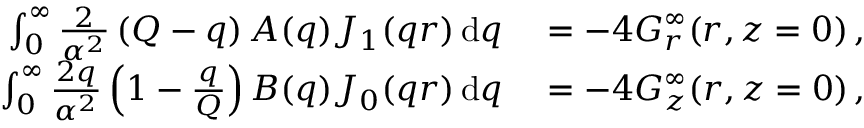Convert formula to latex. <formula><loc_0><loc_0><loc_500><loc_500>\begin{array} { r l } { \int _ { 0 } ^ { \infty } \frac { 2 } { \alpha ^ { 2 } } \left ( Q - q \right ) A ( q ) J _ { 1 } ( q r ) \, d q } & = - 4 G _ { r } ^ { \infty } ( r , z = 0 ) \, , } \\ { \int _ { 0 } ^ { \infty } \frac { 2 q } { \alpha ^ { 2 } } \left ( 1 - \frac { q } { Q } \right ) B ( q ) J _ { 0 } ( q r ) \, d q } & = - 4 G _ { z } ^ { \infty } ( r , z = 0 ) \, , } \end{array}</formula> 